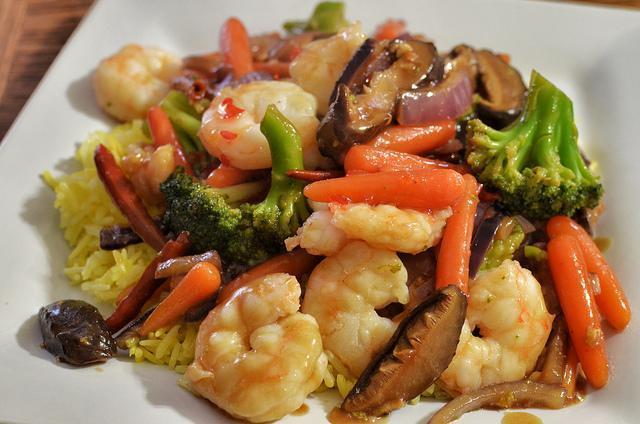How many broccolis can be seen?
Give a very brief answer. 2. How many carrots can you see?
Give a very brief answer. 8. How many people are on the slope?
Give a very brief answer. 0. 